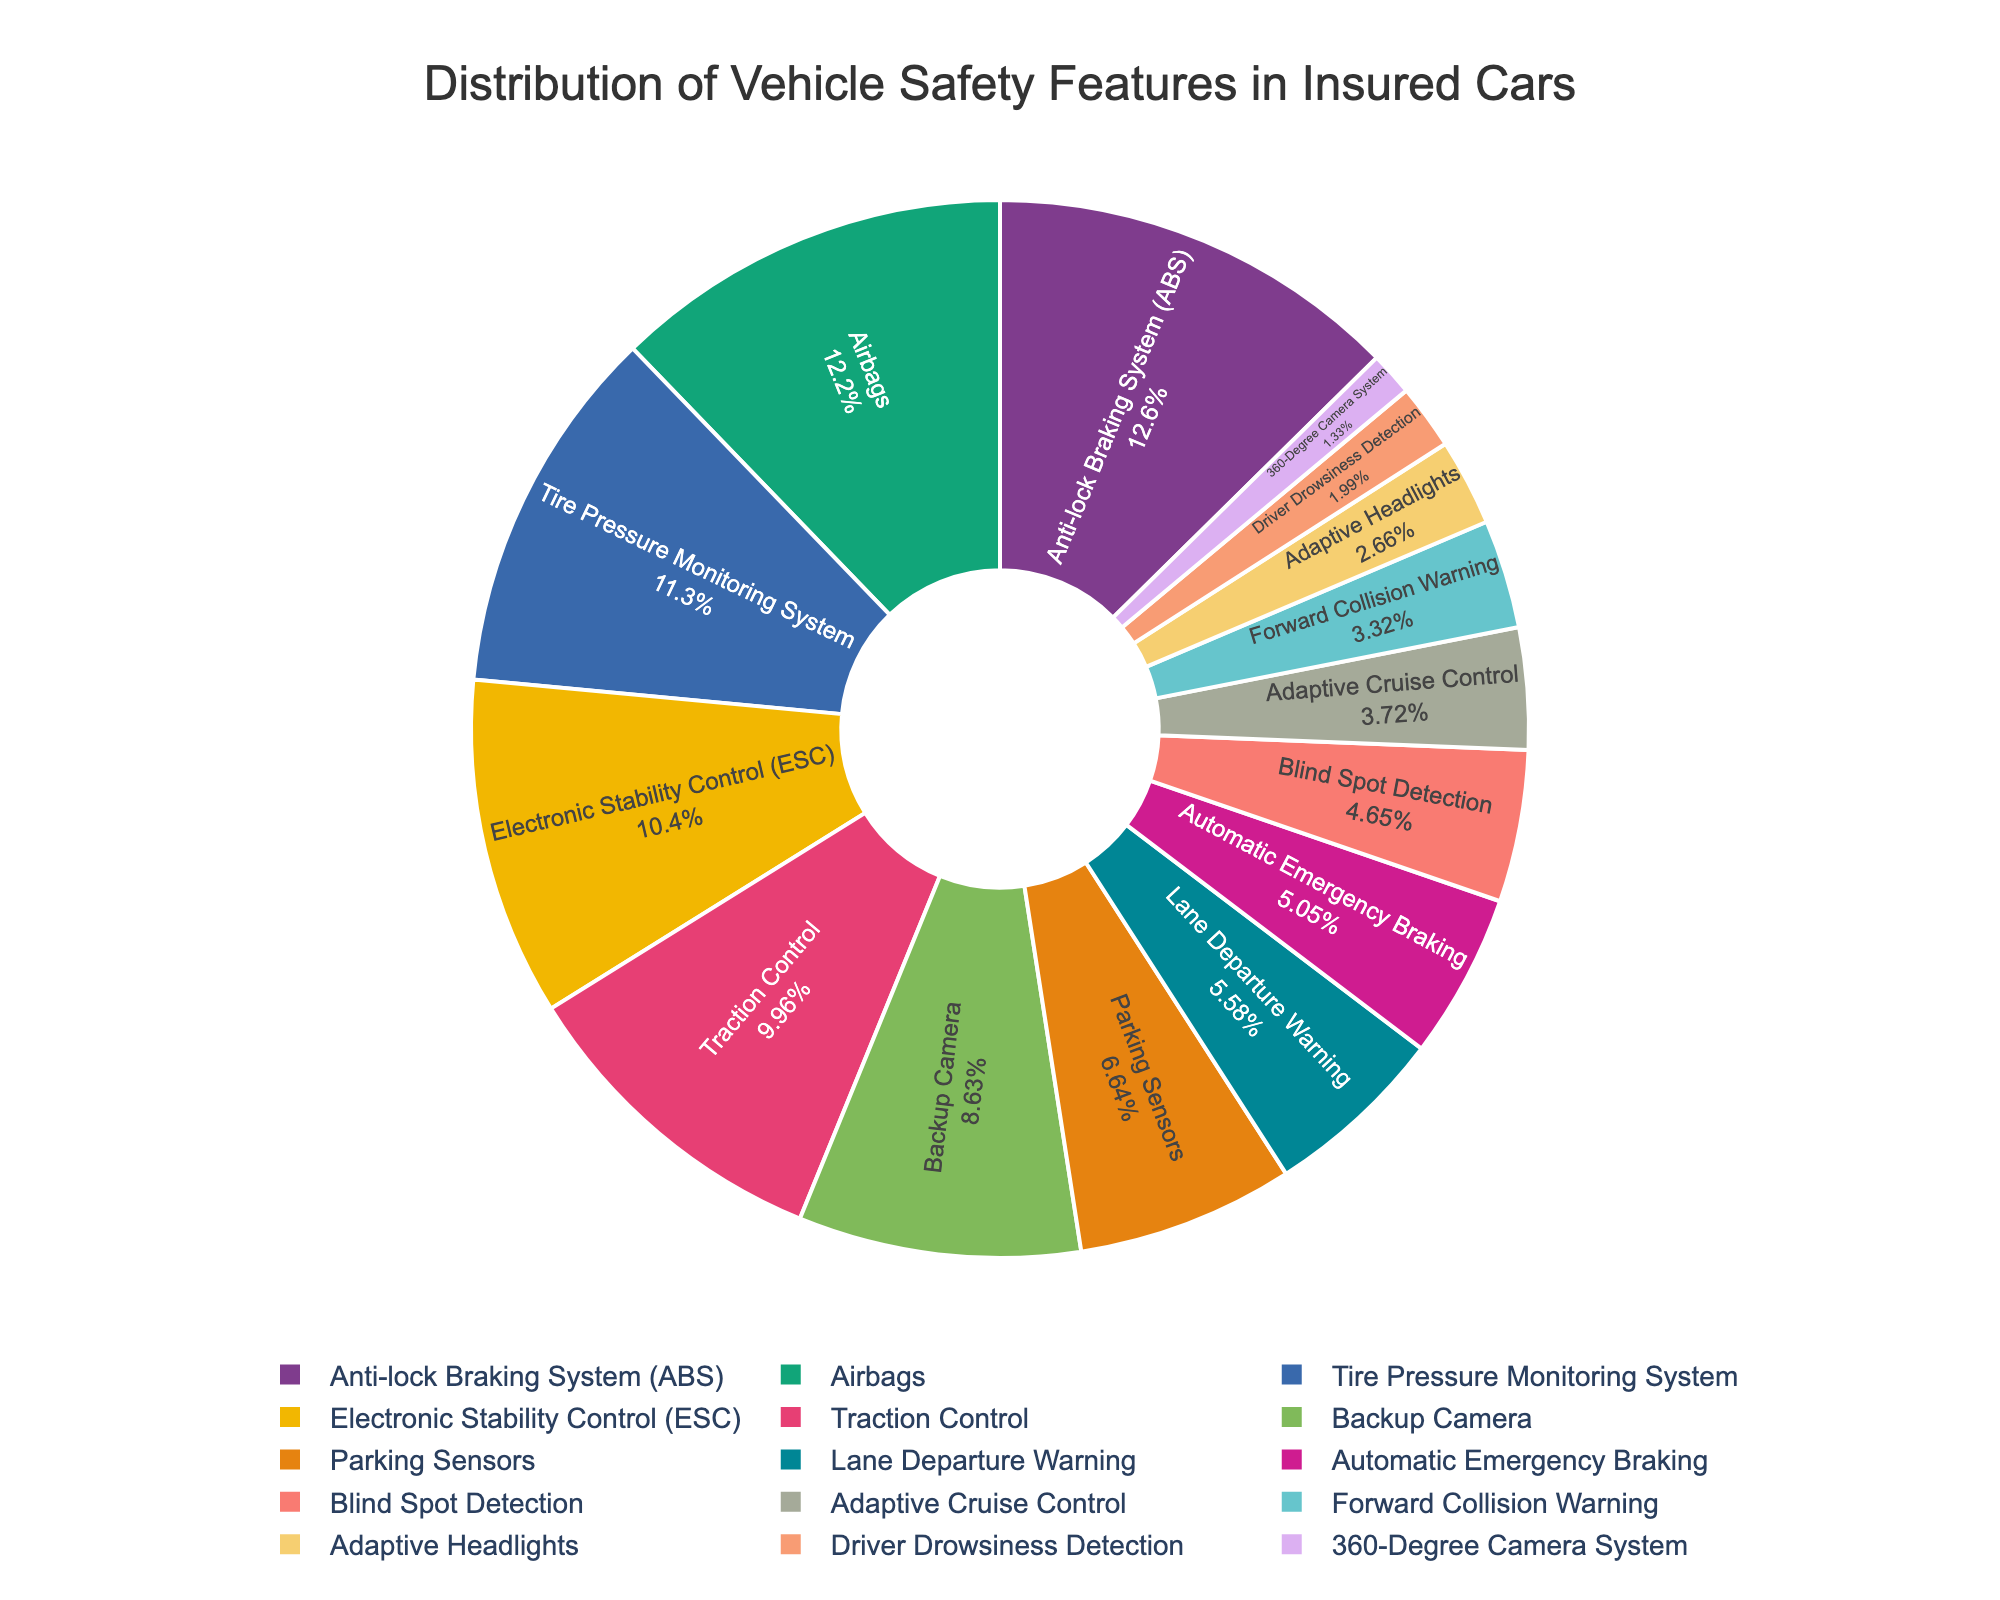What percentage of insured cars have Anti-lock Braking System (ABS)? The slice labeled "Anti-lock Braking System (ABS)" shows the percentage.
Answer: 95% Which safety feature is present in 92% of insured cars? The slice labeled with "Airbags" shows 92%.
Answer: Airbags How does the presence of Blind Spot Detection compare to Forward Collision Warning? Blind Spot Detection is at 35%, while Forward Collision Warning is at 25%.
Answer: Blind Spot Detection is higher What is the combined percentage of cars with Lane Departure Warning and Automatic Emergency Braking? Lane Departure Warning is 42% and Automatic Emergency Braking is 38%. Adding these gives 42% + 38% = 80%.
Answer: 80% Which safety feature is the least common among insured cars? The smallest slice in the pie chart represents "360-Degree Camera System" at 10%.
Answer: 360-Degree Camera System Are backup cameras more common than parking sensors in insured cars? Backup Camera is at 65%, while Parking Sensors is at 50%.
Answer: Yes What is the difference in percentage between Tire Pressure Monitoring System and Traction Control? Tire Pressure Monitoring System is 85%, and Traction Control is 75%. The difference is 85% - 75% = 10%.
Answer: 10% How many safety features are present in less than 30% of insured cars? The features under 30% are Adaptive Cruise Control (28%), Forward Collision Warning (25%), Adaptive Headlights (20%), Driver Drowsiness Detection (15%), and 360-Degree Camera System (10%). There are 5 such features.
Answer: 5 What percentage of insured cars have Electronic Stability Control (ESC) and Adaptive Cruise Control combined? ESC is 78%, and Adaptive Cruise Control is 28%. Adding these gives 78% + 28% = 106%.
Answer: 106% Does the pie chart have any slices represented in a gradient shade? No, the pie chart slices do not show gradient shades; they use bold and pastel colors.
Answer: No 